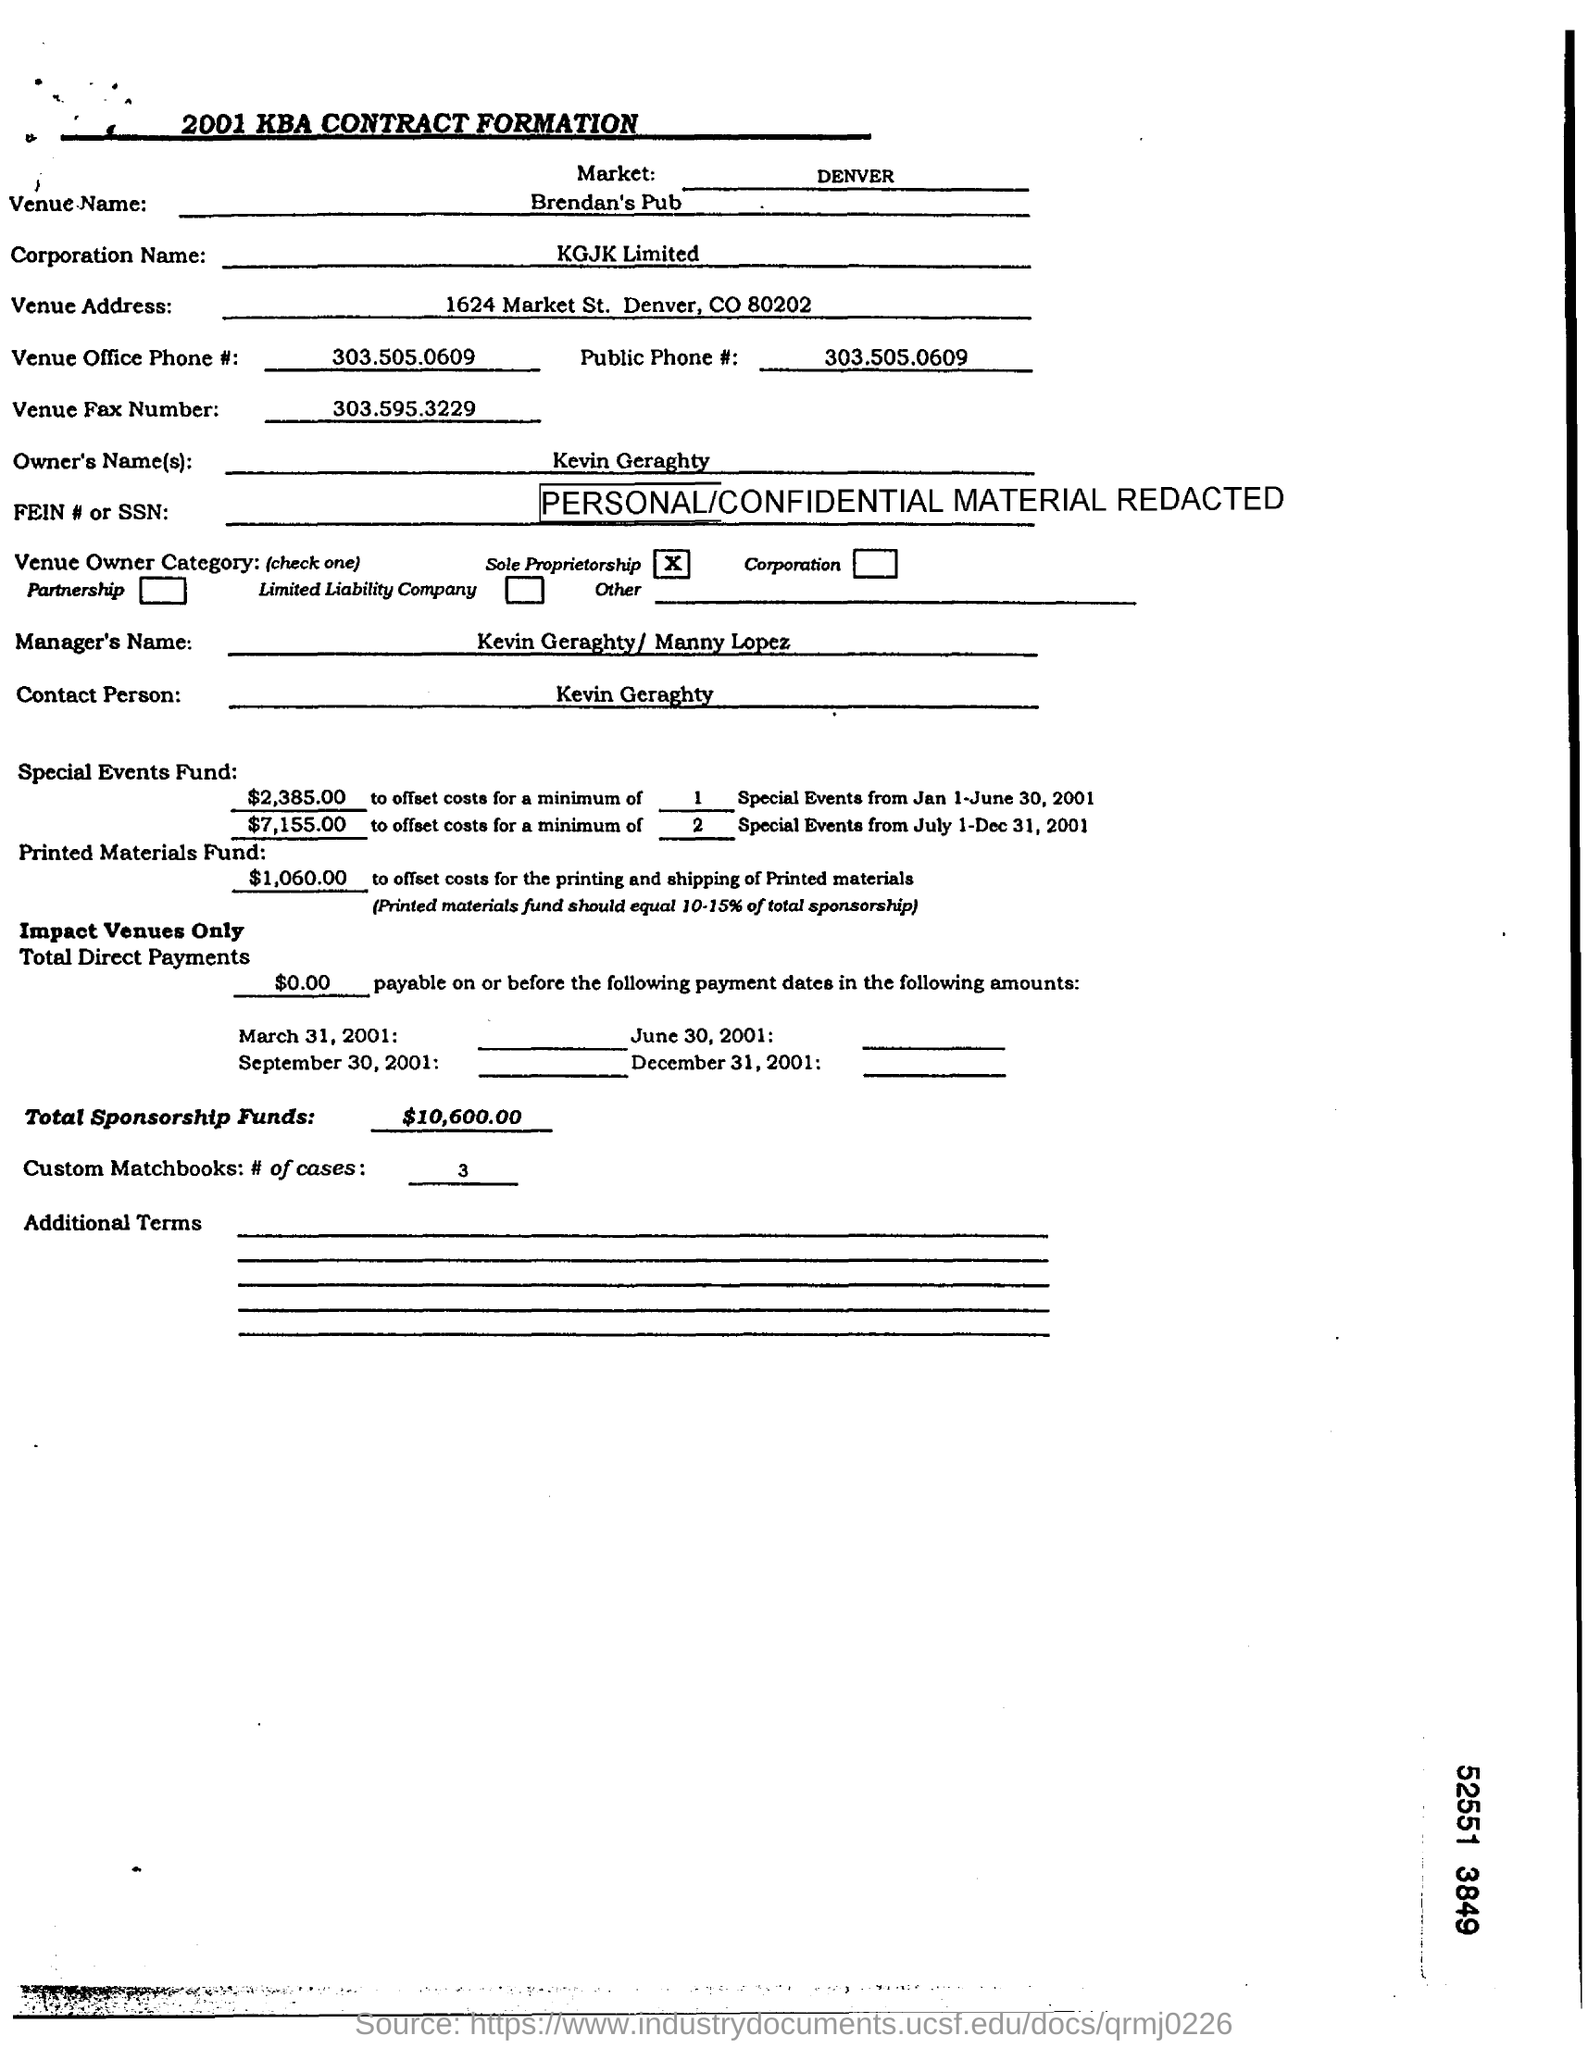List a handful of essential elements in this visual. The owner is Kevin Geraghty. The venue fax number is 303.595.3229. KGJK limited is the name of the corporation. The venue is located at Brendan's Pub. The venue office phone number is 303.505.0609. 